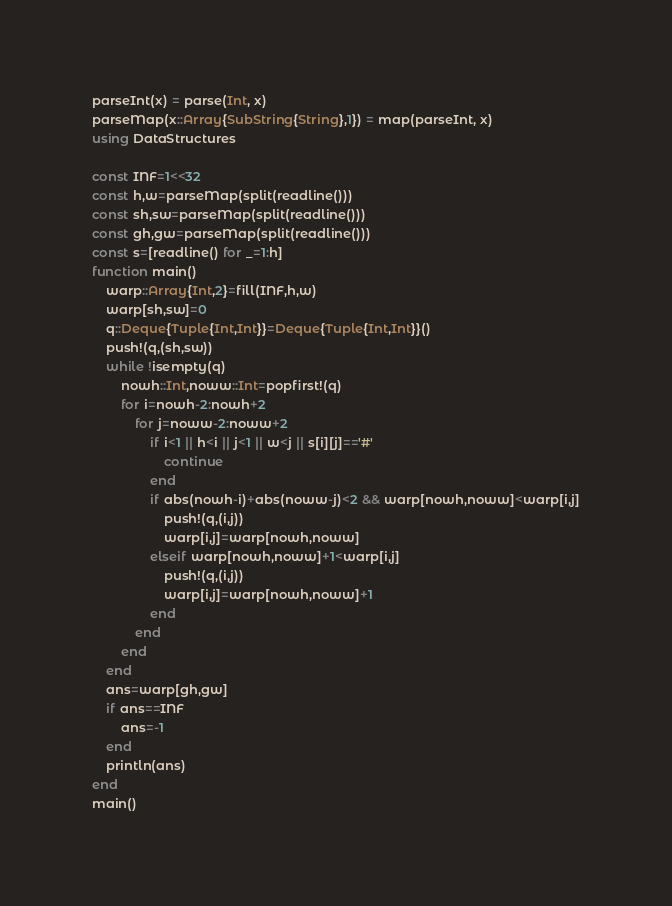Convert code to text. <code><loc_0><loc_0><loc_500><loc_500><_Julia_>parseInt(x) = parse(Int, x)
parseMap(x::Array{SubString{String},1}) = map(parseInt, x)
using DataStructures

const INF=1<<32
const h,w=parseMap(split(readline()))
const sh,sw=parseMap(split(readline()))
const gh,gw=parseMap(split(readline()))
const s=[readline() for _=1:h]
function main()
    warp::Array{Int,2}=fill(INF,h,w)
    warp[sh,sw]=0
    q::Deque{Tuple{Int,Int}}=Deque{Tuple{Int,Int}}()
    push!(q,(sh,sw))
    while !isempty(q)
        nowh::Int,noww::Int=popfirst!(q)
        for i=nowh-2:nowh+2
            for j=noww-2:noww+2
                if i<1 || h<i || j<1 || w<j || s[i][j]=='#'
                    continue
                end
                if abs(nowh-i)+abs(noww-j)<2 && warp[nowh,noww]<warp[i,j]
                    push!(q,(i,j))
                    warp[i,j]=warp[nowh,noww]
                elseif warp[nowh,noww]+1<warp[i,j]
                    push!(q,(i,j))
                    warp[i,j]=warp[nowh,noww]+1
                end
            end
        end
    end
    ans=warp[gh,gw]
    if ans==INF
        ans=-1
    end
    println(ans)
end
main()</code> 